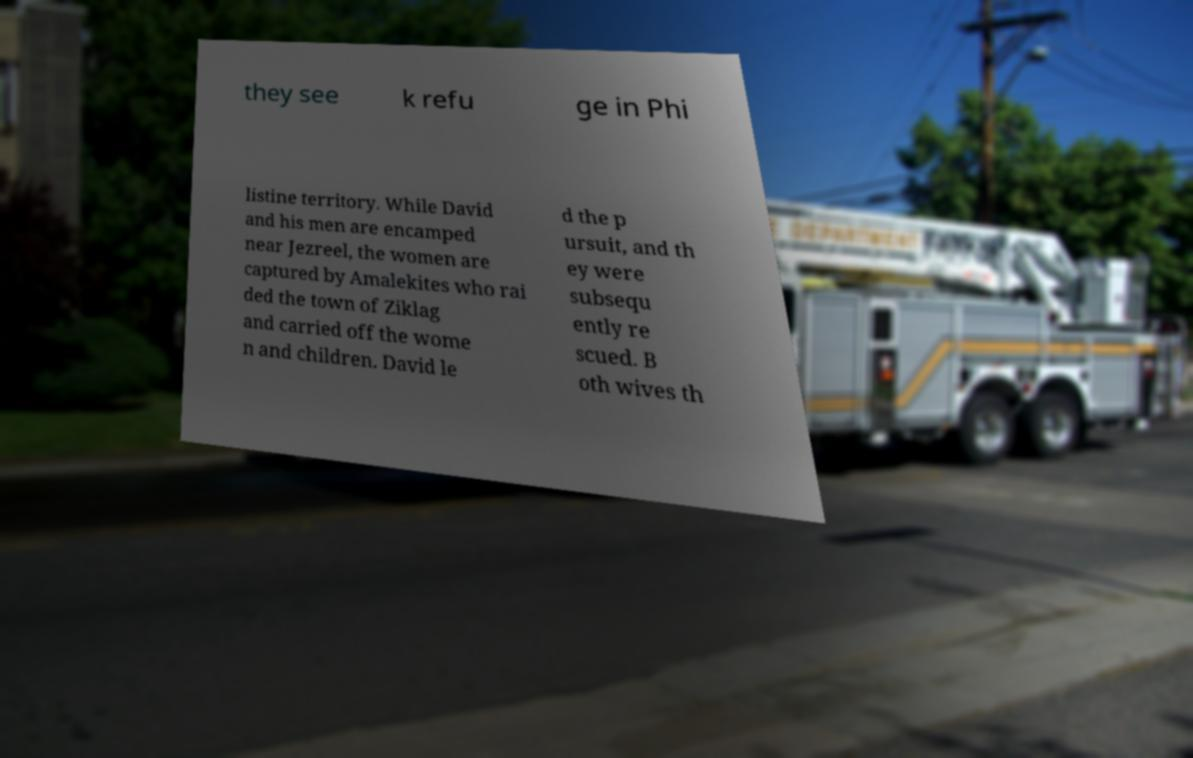Could you extract and type out the text from this image? they see k refu ge in Phi listine territory. While David and his men are encamped near Jezreel, the women are captured by Amalekites who rai ded the town of Ziklag and carried off the wome n and children. David le d the p ursuit, and th ey were subsequ ently re scued. B oth wives th 